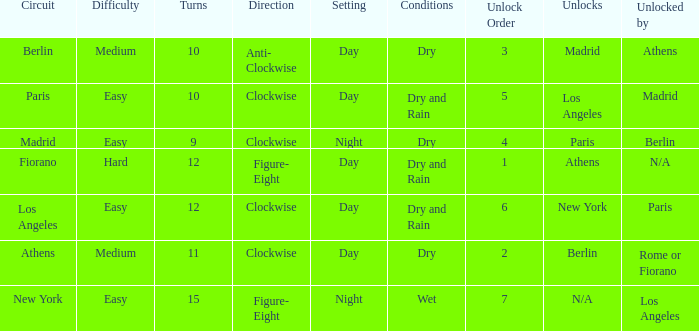What is the setting for the hard difficulty? Day. 